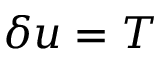<formula> <loc_0><loc_0><loc_500><loc_500>\delta u = T</formula> 